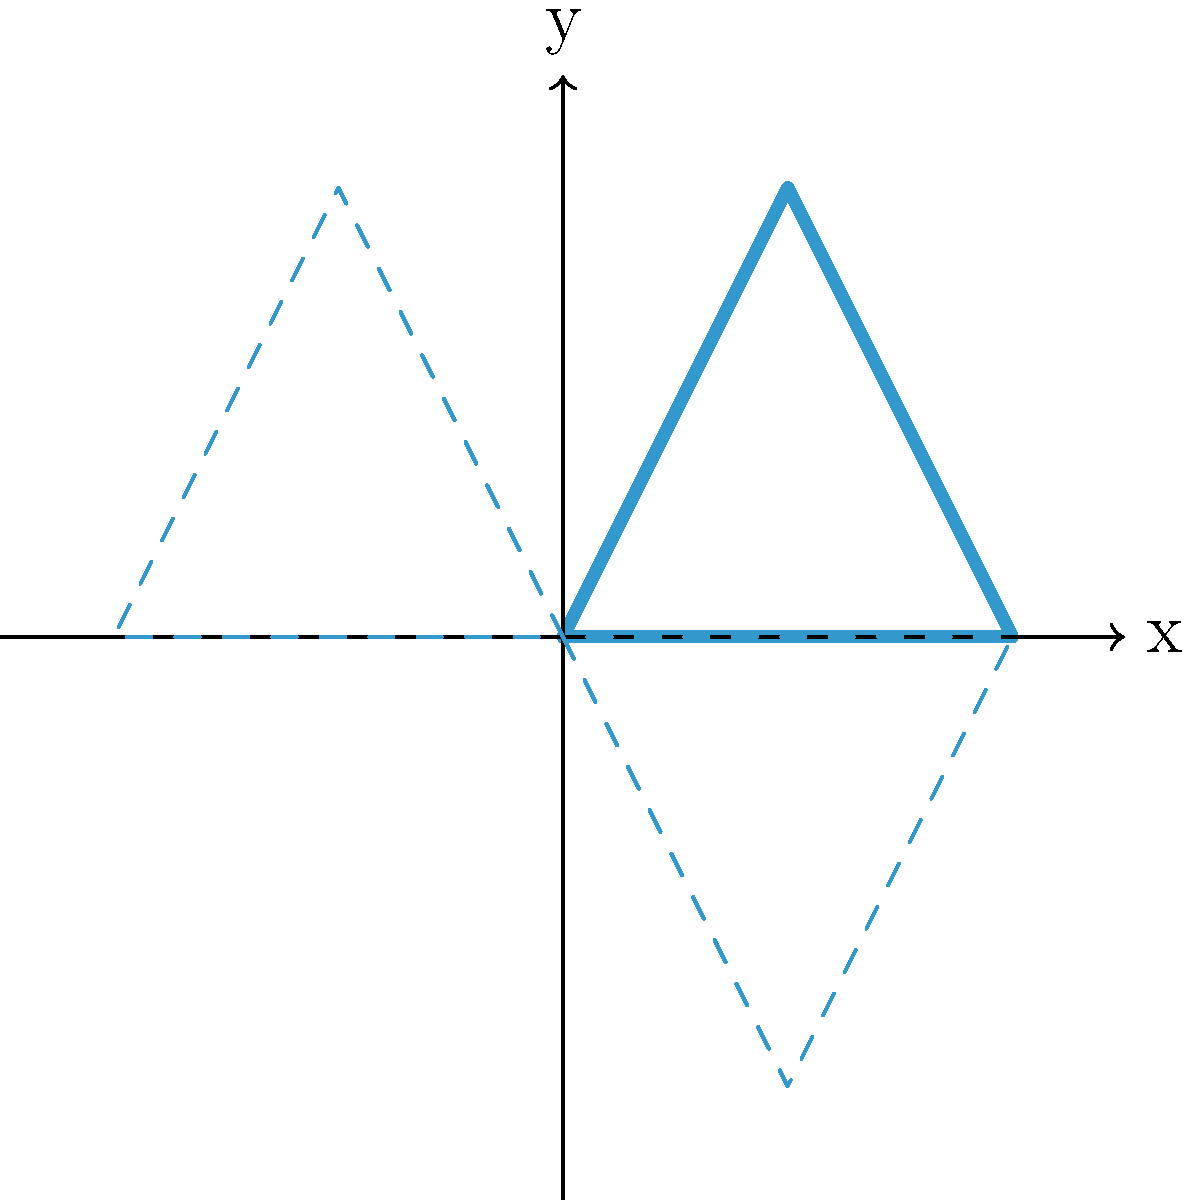Your band's logo is represented by a triangle with vertices at (0,0), (1,2), and (2,0). If you reflect this logo across both the x-axis and y-axis for a symmetrical album cover design, what will be the coordinates of the vertex that was originally at (1,2)? Let's approach this step-by-step:

1) First, let's consider the reflection across the x-axis:
   - The x-coordinate remains the same: 1
   - The y-coordinate changes sign: 2 becomes -2
   - After reflection across x-axis: (1,-2)

2) Now, let's reflect this point (1,-2) across the y-axis:
   - The x-coordinate changes sign: 1 becomes -1
   - The y-coordinate remains the same: -2
   - After reflection across y-axis: (-1,-2)

3) Therefore, after reflecting across both axes, the point (1,2) becomes (-1,-2).

This process creates a symmetrical design where the original logo appears in all four quadrants of the coordinate plane, which could make for an interesting album cover design.
Answer: $(-1,-2)$ 